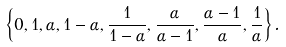Convert formula to latex. <formula><loc_0><loc_0><loc_500><loc_500>\left \{ 0 , 1 , \alpha , 1 - \alpha , \frac { 1 } { 1 - \alpha } , \frac { \alpha } { \alpha - 1 } , \frac { \alpha - 1 } { \alpha } , \frac { 1 } { \alpha } \right \} .</formula> 